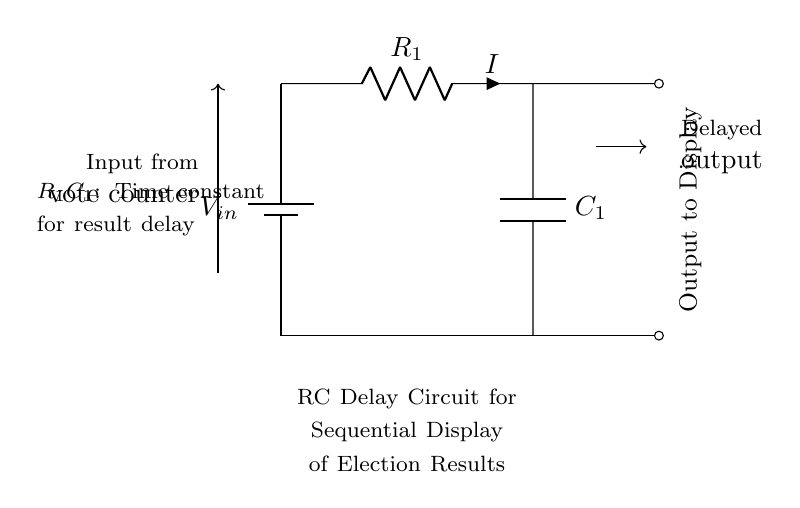What components are in the circuit? The circuit includes a battery, a resistor, and a capacitor. These are essential components in an RC delay circuit, allowing it to store and release energy over time.
Answer: battery, resistor, capacitor What does R_1C_1 represent in this circuit? R_1C_1 denotes the time constant of the RC circuit, which determines how quickly the voltage across the capacitor charges and discharges. It's a product of resistance and capacitance, affecting the delay time before the output signal reflects the input.
Answer: time constant What is the output of this circuit? The output of the circuit is a delayed signal, which represents the results of the vote counting. This signal is produced after the time constant R_1C_1, indicating a gradual transition rather than an instantaneous response.
Answer: delayed output If resistance R_1 is doubled, how does it affect the delay? Doubling R_1 increases the time constant R_1C_1, which leads to a longer delay before the output signal reflects the input. This is because a larger resistance slows down the charging and discharging process of the capacitor.
Answer: increases delay What does the symbol "$I$" signify in this diagram? "$I$" denotes the current flowing through the resistor R_1, which is an important parameter in analyzing the behavior of the circuit as it influences the charge and discharge rates of the capacitor.
Answer: current What type of circuit is represented here? This is an RC delay circuit, specifically designed to create a time delay in the output signal, commonly used in applications requiring sequential display, such as elections results.
Answer: RC delay circuit How can this circuit be used in election results display? The circuit is used to sequentially display election results by delaying the output of the vote data from the counters. This method helps to manage the flow of information and prevents overload during real-time updates.
Answer: sequential display 